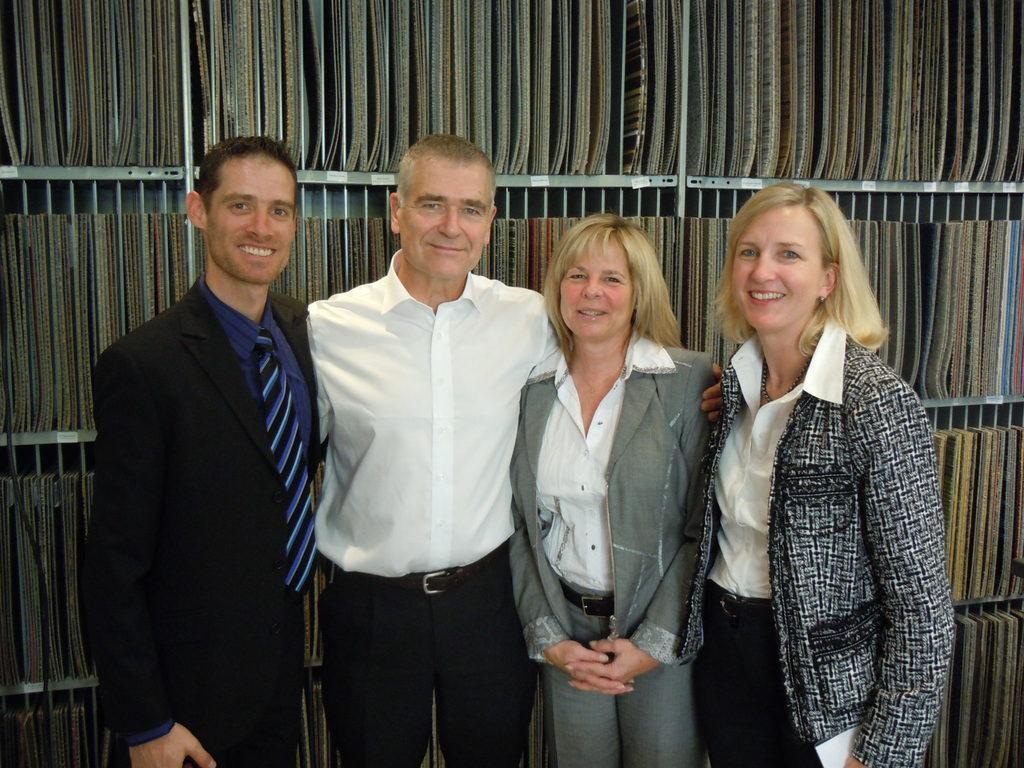Describe this image in one or two sentences. In this image there are two men and two women standing, in the background there is a rack, in that rack there are books. 